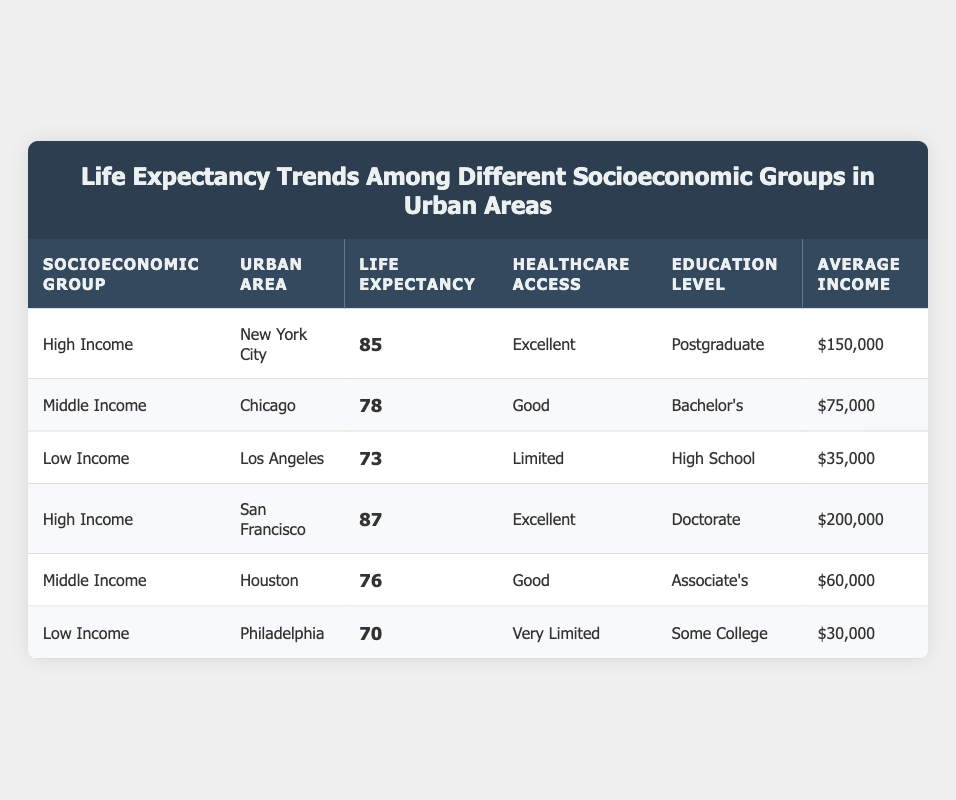What is the life expectancy in New York City? According to the table, New York City is listed under the "High Income" socioeconomic group with a life expectancy of 85 years.
Answer: 85 Which urban area has the lowest life expectancy? The table shows that Philadelphia, under the "Low Income" socioeconomic group, has the lowest life expectancy at 70 years.
Answer: Philadelphia What is the average life expectancy for the Middle Income group? First, we find the life expectancy of the Middle Income group from the table: Chicago has 78 years and Houston has 76 years. The average is (78 + 76) / 2 = 77 years.
Answer: 77 Is the healthcare access in Los Angeles classified as limited? The table lists Los Angeles under the "Low Income" group, where healthcare access is described as "Limited."
Answer: Yes What is the average income of all socioeconomic groups listed? To find the average income, we need to sum the average incomes of each group: 150000 (NYC) + 75000 (Chicago) + 35000 (Los Angeles) + 200000 (San Francisco) + 60000 (Houston) + 30000 (Philadelphia) = 465000. Then divide by 6 (the number of entries): 465000 / 6 = 77500.
Answer: 77500 Which socioeconomic group has the highest education level? The table indicates that the "High Income" group has the highest education levels, with entries of "Postgraduate" for New York City and "Doctorate" for San Francisco.
Answer: High Income How much higher is the life expectancy in San Francisco compared to Philadelphia? From the table, San Francisco has a life expectancy of 87 years, while Philadelphia has 70 years. The difference is 87 - 70 = 17 years.
Answer: 17 years Are there two urban areas listed that have excellent healthcare access? Yes, the table shows that both New York City and San Francisco have "Excellent" healthcare access under the High Income group.
Answer: Yes What is the life expectancy difference between High Income and Low Income groups? The life expectancy for High Income in New York City is 85 years and in San Francisco is 87 years, averaging 86 years. For Low Income, Los Angeles has 73 years and Philadelphia 70 years, averaging 71.5 years. The difference is 86 - 71.5 = 14.5 years.
Answer: 14.5 years 